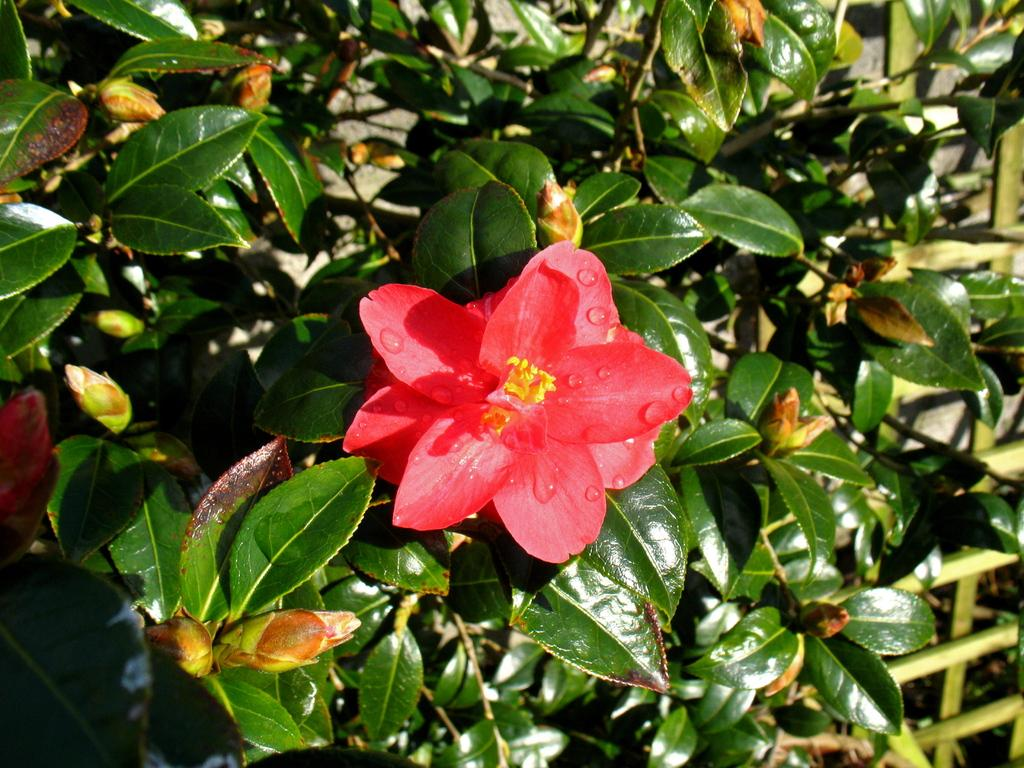What type of plant can be seen in the image? There is a flower in the image. What else is present in the image besides the flower? There are leaves in the image. What type of division is taking place in the image? There is no division present in the image; it features a flower and leaves. Can you see any evidence of a bomb in the image? There is no bomb present in the image; it features a flower and leaves. 